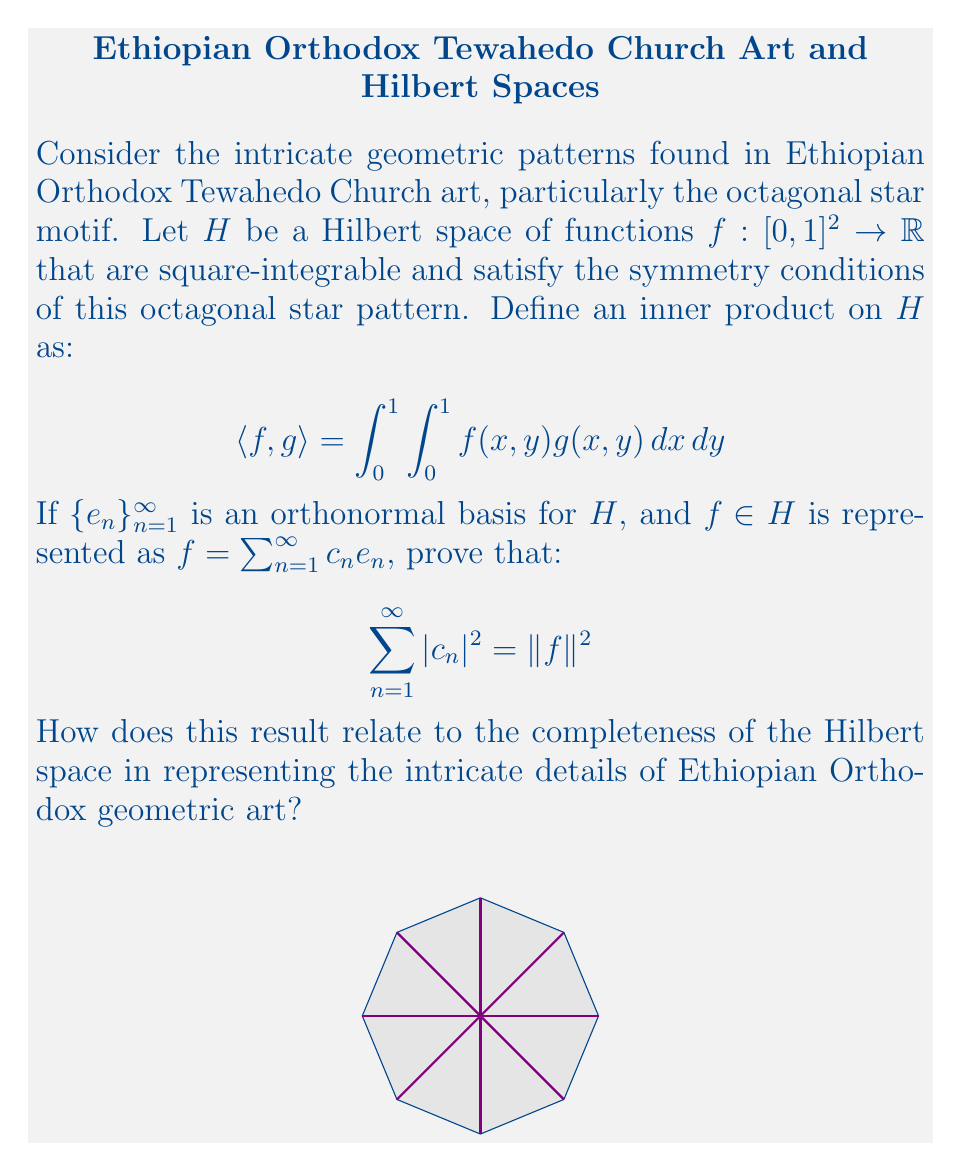Can you solve this math problem? Let's approach this proof step-by-step:

1) First, recall that for an orthonormal basis $\{e_n\}_{n=1}^{\infty}$, we have:
   $$ \langle e_m, e_n \rangle = \delta_{mn} $$
   where $\delta_{mn}$ is the Kronecker delta.

2) Given $f = \sum_{n=1}^{\infty} c_n e_n$, we can compute $\|f\|^2$:
   $$ \|f\|^2 = \langle f, f \rangle = \left\langle \sum_{m=1}^{\infty} c_m e_m, \sum_{n=1}^{\infty} c_n e_n \right\rangle $$

3) Using the linearity of the inner product:
   $$ \|f\|^2 = \sum_{m=1}^{\infty} \sum_{n=1}^{\infty} c_m \overline{c_n} \langle e_m, e_n \rangle $$

4) Applying the orthonormality condition:
   $$ \|f\|^2 = \sum_{m=1}^{\infty} \sum_{n=1}^{\infty} c_m \overline{c_n} \delta_{mn} = \sum_{n=1}^{\infty} c_n \overline{c_n} = \sum_{n=1}^{\infty} |c_n|^2 $$

5) Thus, we have proved that $\sum_{n=1}^{\infty} |c_n|^2 = \|f\|^2$.

This result, known as Parseval's identity, demonstrates the completeness of the Hilbert space in representing the intricate details of Ethiopian Orthodox geometric art. It shows that the energy (squared norm) of a function is equal to the sum of the squared magnitudes of its Fourier coefficients.

In the context of Ethiopian Orthodox geometric art:
- The Hilbert space $H$ represents all possible patterns that satisfy the symmetry of the octagonal star.
- Each basis function $e_n$ can be thought of as a fundamental geometric element.
- The coefficients $c_n$ determine how much of each element is present in a particular pattern.
- The equality $\sum_{n=1}^{\infty} |c_n|^2 = \|f\|^2$ ensures that we can represent any pattern in $H$ with arbitrary precision using these fundamental elements, capturing all the intricate details of the artwork.

This completeness is crucial for preserving and analyzing the rich geometric traditions in Ethiopian Orthodox art, allowing for a mathematical framework to study and reproduce these complex patterns.
Answer: Parseval's identity: $\sum_{n=1}^{\infty} |c_n|^2 = \|f\|^2$ 